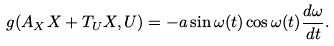Convert formula to latex. <formula><loc_0><loc_0><loc_500><loc_500>g ( A _ { X } X + T _ { U } X , U ) = - a \sin \omega ( t ) \cos \omega ( t ) \frac { d \omega } { d t } .</formula> 